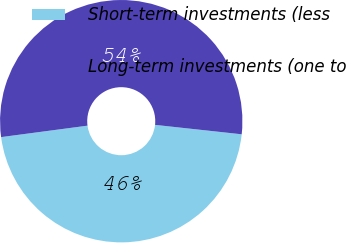<chart> <loc_0><loc_0><loc_500><loc_500><pie_chart><fcel>Short-term investments (less<fcel>Long-term investments (one to<nl><fcel>46.18%<fcel>53.82%<nl></chart> 